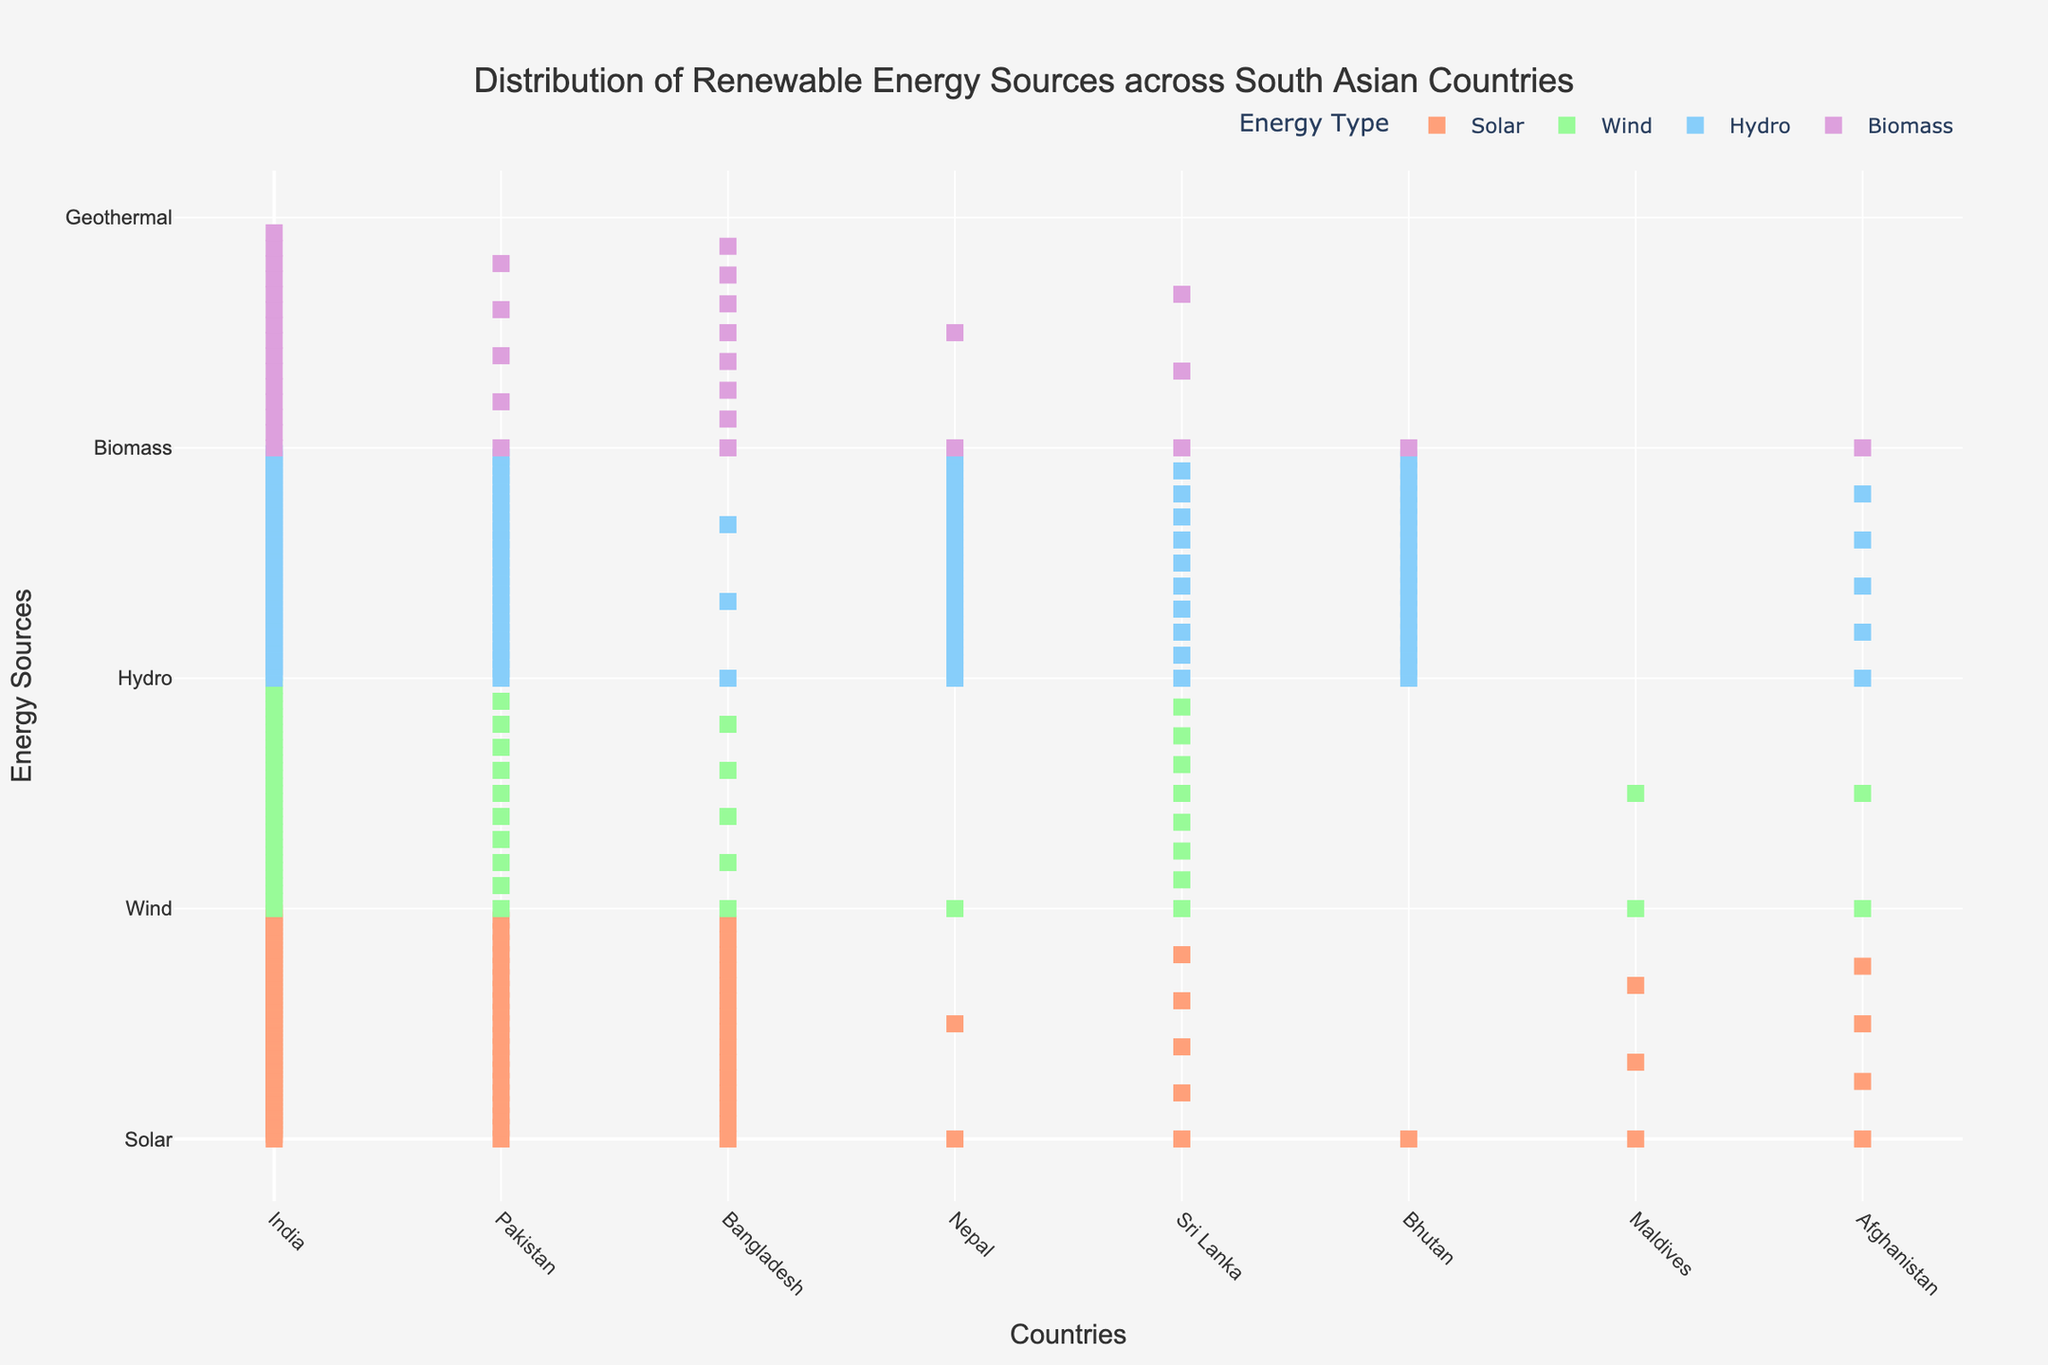What's the title of the figure? The title of the figure is located at the top and reads 'Distribution of Renewable Energy Sources across South Asian Countries'.
Answer: Distribution of Renewable Energy Sources across South Asian Countries Which country has the highest number of hydro energy sources? By looking at the count of hydro energy markers, India has the highest number with 40 hydro energy markers.
Answer: India What is the total number of solar energy sources for India and Pakistan combined? Add the number of solar energy markers for India (50) and Pakistan (20). So, 50 + 20 = 70
Answer: 70 How many types of renewable energy sources are represented in the plot? The y-axis lists the different types of renewable energy sources. There are five types: Solar, Wind, Hydro, Biomass, and Geothermal.
Answer: 5 Which country has the least number of wind energy sources? By counting the wind energy markers, both Bhutan and Nepal have the least number of wind energy sources with just 1 marker each.
Answer: Bhutan and Nepal Does any country have geothermal energy as a renewable energy source? By observing the plot, all countries have zero markers for geothermal energy, indicating none of the countries use geothermal energy.
Answer: No Compare the biomass energy sources between Bangladesh and Sri Lanka. Which country has more, and by what amount? Bangladesh has 8 biomass energy markers, while Sri Lanka has 3. So, Bangladesh has 8 - 3 = 5 more biomass energy sources than Sri Lanka.
Answer: Bangladesh by 5 How many countries have biomass as part of their renewable energy sources? Count the number of countries with biomass markers. There are six: India, Pakistan, Bangladesh, Nepal, Sri Lanka, and Afghanistan.
Answer: 6 What's the average number of hydro energy sources across all countries? Sum the hydro energy sources for all countries (40 + 25 + 3 + 30 + 10 + 20 + 0 + 5 = 133). Divide by the number of countries (8): 133 / 8 ≈ 16.625
Answer: 16.625 Which country relies most on wind energy as a renewable source compared to others? By comparing the wind energy markers, India has the most with 30 wind energy markers.
Answer: India 